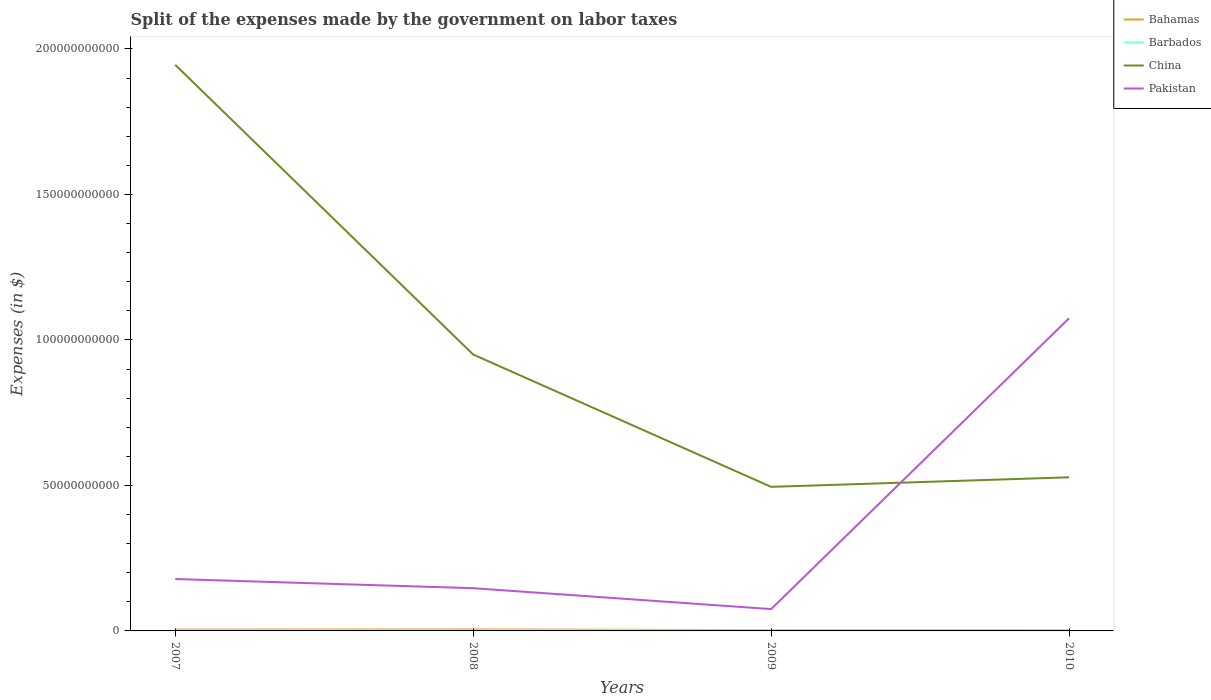Does the line corresponding to China intersect with the line corresponding to Pakistan?
Your response must be concise. Yes. Across all years, what is the maximum expenses made by the government on labor taxes in Pakistan?
Offer a very short reply. 7.50e+09. In which year was the expenses made by the government on labor taxes in Pakistan maximum?
Keep it short and to the point. 2009. What is the total expenses made by the government on labor taxes in China in the graph?
Your answer should be compact. 4.55e+1. What is the difference between the highest and the second highest expenses made by the government on labor taxes in China?
Ensure brevity in your answer.  1.45e+11. What is the difference between the highest and the lowest expenses made by the government on labor taxes in China?
Give a very brief answer. 1. How many lines are there?
Offer a terse response. 4. Are the values on the major ticks of Y-axis written in scientific E-notation?
Your answer should be compact. No. Does the graph contain any zero values?
Give a very brief answer. No. Does the graph contain grids?
Offer a terse response. No. How are the legend labels stacked?
Ensure brevity in your answer.  Vertical. What is the title of the graph?
Your answer should be compact. Split of the expenses made by the government on labor taxes. Does "Middle East & North Africa (all income levels)" appear as one of the legend labels in the graph?
Provide a short and direct response. No. What is the label or title of the Y-axis?
Your answer should be compact. Expenses (in $). What is the Expenses (in $) of Bahamas in 2007?
Your response must be concise. 4.46e+08. What is the Expenses (in $) in Barbados in 2007?
Offer a very short reply. 2.17e+08. What is the Expenses (in $) of China in 2007?
Your answer should be very brief. 1.95e+11. What is the Expenses (in $) in Pakistan in 2007?
Make the answer very short. 1.78e+1. What is the Expenses (in $) of Bahamas in 2008?
Your answer should be very brief. 4.99e+08. What is the Expenses (in $) in Barbados in 2008?
Give a very brief answer. 2.42e+08. What is the Expenses (in $) of China in 2008?
Ensure brevity in your answer.  9.50e+1. What is the Expenses (in $) of Pakistan in 2008?
Provide a short and direct response. 1.47e+1. What is the Expenses (in $) of Bahamas in 2009?
Give a very brief answer. 2.78e+08. What is the Expenses (in $) of Barbados in 2009?
Make the answer very short. 2.18e+08. What is the Expenses (in $) of China in 2009?
Give a very brief answer. 4.95e+1. What is the Expenses (in $) of Pakistan in 2009?
Offer a very short reply. 7.50e+09. What is the Expenses (in $) of Bahamas in 2010?
Your answer should be very brief. 2.53e+08. What is the Expenses (in $) in Barbados in 2010?
Your answer should be compact. 2.13e+08. What is the Expenses (in $) of China in 2010?
Your answer should be very brief. 5.28e+1. What is the Expenses (in $) in Pakistan in 2010?
Provide a short and direct response. 1.07e+11. Across all years, what is the maximum Expenses (in $) in Bahamas?
Your response must be concise. 4.99e+08. Across all years, what is the maximum Expenses (in $) in Barbados?
Offer a terse response. 2.42e+08. Across all years, what is the maximum Expenses (in $) in China?
Ensure brevity in your answer.  1.95e+11. Across all years, what is the maximum Expenses (in $) of Pakistan?
Offer a terse response. 1.07e+11. Across all years, what is the minimum Expenses (in $) of Bahamas?
Your answer should be very brief. 2.53e+08. Across all years, what is the minimum Expenses (in $) of Barbados?
Provide a succinct answer. 2.13e+08. Across all years, what is the minimum Expenses (in $) of China?
Your answer should be very brief. 4.95e+1. Across all years, what is the minimum Expenses (in $) of Pakistan?
Ensure brevity in your answer.  7.50e+09. What is the total Expenses (in $) in Bahamas in the graph?
Keep it short and to the point. 1.48e+09. What is the total Expenses (in $) in Barbados in the graph?
Provide a succinct answer. 8.90e+08. What is the total Expenses (in $) in China in the graph?
Your response must be concise. 3.92e+11. What is the total Expenses (in $) in Pakistan in the graph?
Provide a succinct answer. 1.47e+11. What is the difference between the Expenses (in $) in Bahamas in 2007 and that in 2008?
Offer a terse response. -5.32e+07. What is the difference between the Expenses (in $) of Barbados in 2007 and that in 2008?
Keep it short and to the point. -2.51e+07. What is the difference between the Expenses (in $) of China in 2007 and that in 2008?
Offer a terse response. 9.95e+1. What is the difference between the Expenses (in $) in Pakistan in 2007 and that in 2008?
Keep it short and to the point. 3.14e+09. What is the difference between the Expenses (in $) in Bahamas in 2007 and that in 2009?
Keep it short and to the point. 1.68e+08. What is the difference between the Expenses (in $) in Barbados in 2007 and that in 2009?
Keep it short and to the point. -1.56e+06. What is the difference between the Expenses (in $) in China in 2007 and that in 2009?
Offer a terse response. 1.45e+11. What is the difference between the Expenses (in $) of Pakistan in 2007 and that in 2009?
Offer a very short reply. 1.03e+1. What is the difference between the Expenses (in $) of Bahamas in 2007 and that in 2010?
Ensure brevity in your answer.  1.92e+08. What is the difference between the Expenses (in $) of Barbados in 2007 and that in 2010?
Provide a short and direct response. 3.69e+06. What is the difference between the Expenses (in $) in China in 2007 and that in 2010?
Make the answer very short. 1.42e+11. What is the difference between the Expenses (in $) of Pakistan in 2007 and that in 2010?
Your response must be concise. -8.96e+1. What is the difference between the Expenses (in $) in Bahamas in 2008 and that in 2009?
Provide a succinct answer. 2.21e+08. What is the difference between the Expenses (in $) in Barbados in 2008 and that in 2009?
Offer a terse response. 2.35e+07. What is the difference between the Expenses (in $) in China in 2008 and that in 2009?
Give a very brief answer. 4.55e+1. What is the difference between the Expenses (in $) of Pakistan in 2008 and that in 2009?
Give a very brief answer. 7.18e+09. What is the difference between the Expenses (in $) of Bahamas in 2008 and that in 2010?
Keep it short and to the point. 2.46e+08. What is the difference between the Expenses (in $) of Barbados in 2008 and that in 2010?
Keep it short and to the point. 2.88e+07. What is the difference between the Expenses (in $) in China in 2008 and that in 2010?
Your response must be concise. 4.22e+1. What is the difference between the Expenses (in $) in Pakistan in 2008 and that in 2010?
Provide a short and direct response. -9.28e+1. What is the difference between the Expenses (in $) in Bahamas in 2009 and that in 2010?
Give a very brief answer. 2.47e+07. What is the difference between the Expenses (in $) in Barbados in 2009 and that in 2010?
Your answer should be compact. 5.25e+06. What is the difference between the Expenses (in $) of China in 2009 and that in 2010?
Ensure brevity in your answer.  -3.28e+09. What is the difference between the Expenses (in $) of Pakistan in 2009 and that in 2010?
Ensure brevity in your answer.  -9.99e+1. What is the difference between the Expenses (in $) of Bahamas in 2007 and the Expenses (in $) of Barbados in 2008?
Keep it short and to the point. 2.04e+08. What is the difference between the Expenses (in $) of Bahamas in 2007 and the Expenses (in $) of China in 2008?
Keep it short and to the point. -9.45e+1. What is the difference between the Expenses (in $) in Bahamas in 2007 and the Expenses (in $) in Pakistan in 2008?
Your answer should be very brief. -1.42e+1. What is the difference between the Expenses (in $) in Barbados in 2007 and the Expenses (in $) in China in 2008?
Provide a short and direct response. -9.48e+1. What is the difference between the Expenses (in $) in Barbados in 2007 and the Expenses (in $) in Pakistan in 2008?
Provide a succinct answer. -1.45e+1. What is the difference between the Expenses (in $) in China in 2007 and the Expenses (in $) in Pakistan in 2008?
Offer a terse response. 1.80e+11. What is the difference between the Expenses (in $) in Bahamas in 2007 and the Expenses (in $) in Barbados in 2009?
Make the answer very short. 2.27e+08. What is the difference between the Expenses (in $) in Bahamas in 2007 and the Expenses (in $) in China in 2009?
Your answer should be compact. -4.91e+1. What is the difference between the Expenses (in $) of Bahamas in 2007 and the Expenses (in $) of Pakistan in 2009?
Keep it short and to the point. -7.06e+09. What is the difference between the Expenses (in $) of Barbados in 2007 and the Expenses (in $) of China in 2009?
Offer a terse response. -4.93e+1. What is the difference between the Expenses (in $) of Barbados in 2007 and the Expenses (in $) of Pakistan in 2009?
Your answer should be very brief. -7.29e+09. What is the difference between the Expenses (in $) in China in 2007 and the Expenses (in $) in Pakistan in 2009?
Provide a succinct answer. 1.87e+11. What is the difference between the Expenses (in $) in Bahamas in 2007 and the Expenses (in $) in Barbados in 2010?
Make the answer very short. 2.32e+08. What is the difference between the Expenses (in $) in Bahamas in 2007 and the Expenses (in $) in China in 2010?
Offer a very short reply. -5.23e+1. What is the difference between the Expenses (in $) of Bahamas in 2007 and the Expenses (in $) of Pakistan in 2010?
Make the answer very short. -1.07e+11. What is the difference between the Expenses (in $) in Barbados in 2007 and the Expenses (in $) in China in 2010?
Your response must be concise. -5.26e+1. What is the difference between the Expenses (in $) of Barbados in 2007 and the Expenses (in $) of Pakistan in 2010?
Your answer should be compact. -1.07e+11. What is the difference between the Expenses (in $) in China in 2007 and the Expenses (in $) in Pakistan in 2010?
Offer a very short reply. 8.71e+1. What is the difference between the Expenses (in $) in Bahamas in 2008 and the Expenses (in $) in Barbados in 2009?
Offer a very short reply. 2.80e+08. What is the difference between the Expenses (in $) of Bahamas in 2008 and the Expenses (in $) of China in 2009?
Keep it short and to the point. -4.90e+1. What is the difference between the Expenses (in $) in Bahamas in 2008 and the Expenses (in $) in Pakistan in 2009?
Keep it short and to the point. -7.00e+09. What is the difference between the Expenses (in $) of Barbados in 2008 and the Expenses (in $) of China in 2009?
Your answer should be very brief. -4.93e+1. What is the difference between the Expenses (in $) of Barbados in 2008 and the Expenses (in $) of Pakistan in 2009?
Make the answer very short. -7.26e+09. What is the difference between the Expenses (in $) of China in 2008 and the Expenses (in $) of Pakistan in 2009?
Give a very brief answer. 8.75e+1. What is the difference between the Expenses (in $) of Bahamas in 2008 and the Expenses (in $) of Barbados in 2010?
Your answer should be very brief. 2.86e+08. What is the difference between the Expenses (in $) in Bahamas in 2008 and the Expenses (in $) in China in 2010?
Offer a very short reply. -5.23e+1. What is the difference between the Expenses (in $) of Bahamas in 2008 and the Expenses (in $) of Pakistan in 2010?
Offer a terse response. -1.07e+11. What is the difference between the Expenses (in $) of Barbados in 2008 and the Expenses (in $) of China in 2010?
Offer a very short reply. -5.25e+1. What is the difference between the Expenses (in $) in Barbados in 2008 and the Expenses (in $) in Pakistan in 2010?
Provide a short and direct response. -1.07e+11. What is the difference between the Expenses (in $) in China in 2008 and the Expenses (in $) in Pakistan in 2010?
Keep it short and to the point. -1.25e+1. What is the difference between the Expenses (in $) in Bahamas in 2009 and the Expenses (in $) in Barbados in 2010?
Provide a succinct answer. 6.47e+07. What is the difference between the Expenses (in $) in Bahamas in 2009 and the Expenses (in $) in China in 2010?
Your response must be concise. -5.25e+1. What is the difference between the Expenses (in $) of Bahamas in 2009 and the Expenses (in $) of Pakistan in 2010?
Give a very brief answer. -1.07e+11. What is the difference between the Expenses (in $) in Barbados in 2009 and the Expenses (in $) in China in 2010?
Make the answer very short. -5.26e+1. What is the difference between the Expenses (in $) in Barbados in 2009 and the Expenses (in $) in Pakistan in 2010?
Make the answer very short. -1.07e+11. What is the difference between the Expenses (in $) of China in 2009 and the Expenses (in $) of Pakistan in 2010?
Make the answer very short. -5.79e+1. What is the average Expenses (in $) of Bahamas per year?
Keep it short and to the point. 3.69e+08. What is the average Expenses (in $) in Barbados per year?
Keep it short and to the point. 2.23e+08. What is the average Expenses (in $) of China per year?
Your response must be concise. 9.79e+1. What is the average Expenses (in $) of Pakistan per year?
Offer a very short reply. 3.69e+1. In the year 2007, what is the difference between the Expenses (in $) in Bahamas and Expenses (in $) in Barbados?
Ensure brevity in your answer.  2.29e+08. In the year 2007, what is the difference between the Expenses (in $) of Bahamas and Expenses (in $) of China?
Offer a terse response. -1.94e+11. In the year 2007, what is the difference between the Expenses (in $) of Bahamas and Expenses (in $) of Pakistan?
Provide a short and direct response. -1.74e+1. In the year 2007, what is the difference between the Expenses (in $) in Barbados and Expenses (in $) in China?
Your answer should be very brief. -1.94e+11. In the year 2007, what is the difference between the Expenses (in $) of Barbados and Expenses (in $) of Pakistan?
Offer a very short reply. -1.76e+1. In the year 2007, what is the difference between the Expenses (in $) of China and Expenses (in $) of Pakistan?
Provide a short and direct response. 1.77e+11. In the year 2008, what is the difference between the Expenses (in $) in Bahamas and Expenses (in $) in Barbados?
Provide a short and direct response. 2.57e+08. In the year 2008, what is the difference between the Expenses (in $) of Bahamas and Expenses (in $) of China?
Offer a very short reply. -9.45e+1. In the year 2008, what is the difference between the Expenses (in $) in Bahamas and Expenses (in $) in Pakistan?
Offer a terse response. -1.42e+1. In the year 2008, what is the difference between the Expenses (in $) of Barbados and Expenses (in $) of China?
Offer a very short reply. -9.47e+1. In the year 2008, what is the difference between the Expenses (in $) in Barbados and Expenses (in $) in Pakistan?
Your response must be concise. -1.44e+1. In the year 2008, what is the difference between the Expenses (in $) in China and Expenses (in $) in Pakistan?
Your response must be concise. 8.03e+1. In the year 2009, what is the difference between the Expenses (in $) of Bahamas and Expenses (in $) of Barbados?
Your answer should be compact. 5.95e+07. In the year 2009, what is the difference between the Expenses (in $) of Bahamas and Expenses (in $) of China?
Give a very brief answer. -4.92e+1. In the year 2009, what is the difference between the Expenses (in $) in Bahamas and Expenses (in $) in Pakistan?
Ensure brevity in your answer.  -7.23e+09. In the year 2009, what is the difference between the Expenses (in $) of Barbados and Expenses (in $) of China?
Provide a succinct answer. -4.93e+1. In the year 2009, what is the difference between the Expenses (in $) of Barbados and Expenses (in $) of Pakistan?
Your answer should be very brief. -7.28e+09. In the year 2009, what is the difference between the Expenses (in $) of China and Expenses (in $) of Pakistan?
Your response must be concise. 4.20e+1. In the year 2010, what is the difference between the Expenses (in $) of Bahamas and Expenses (in $) of Barbados?
Your answer should be very brief. 4.00e+07. In the year 2010, what is the difference between the Expenses (in $) of Bahamas and Expenses (in $) of China?
Ensure brevity in your answer.  -5.25e+1. In the year 2010, what is the difference between the Expenses (in $) in Bahamas and Expenses (in $) in Pakistan?
Your answer should be very brief. -1.07e+11. In the year 2010, what is the difference between the Expenses (in $) of Barbados and Expenses (in $) of China?
Offer a terse response. -5.26e+1. In the year 2010, what is the difference between the Expenses (in $) of Barbados and Expenses (in $) of Pakistan?
Provide a succinct answer. -1.07e+11. In the year 2010, what is the difference between the Expenses (in $) of China and Expenses (in $) of Pakistan?
Make the answer very short. -5.47e+1. What is the ratio of the Expenses (in $) in Bahamas in 2007 to that in 2008?
Provide a short and direct response. 0.89. What is the ratio of the Expenses (in $) in Barbados in 2007 to that in 2008?
Provide a short and direct response. 0.9. What is the ratio of the Expenses (in $) of China in 2007 to that in 2008?
Give a very brief answer. 2.05. What is the ratio of the Expenses (in $) of Pakistan in 2007 to that in 2008?
Ensure brevity in your answer.  1.21. What is the ratio of the Expenses (in $) in Bahamas in 2007 to that in 2009?
Your answer should be very brief. 1.6. What is the ratio of the Expenses (in $) of China in 2007 to that in 2009?
Keep it short and to the point. 3.93. What is the ratio of the Expenses (in $) of Pakistan in 2007 to that in 2009?
Make the answer very short. 2.38. What is the ratio of the Expenses (in $) of Bahamas in 2007 to that in 2010?
Ensure brevity in your answer.  1.76. What is the ratio of the Expenses (in $) in Barbados in 2007 to that in 2010?
Your answer should be very brief. 1.02. What is the ratio of the Expenses (in $) in China in 2007 to that in 2010?
Offer a terse response. 3.69. What is the ratio of the Expenses (in $) in Pakistan in 2007 to that in 2010?
Your answer should be very brief. 0.17. What is the ratio of the Expenses (in $) in Bahamas in 2008 to that in 2009?
Your response must be concise. 1.79. What is the ratio of the Expenses (in $) of Barbados in 2008 to that in 2009?
Offer a terse response. 1.11. What is the ratio of the Expenses (in $) of China in 2008 to that in 2009?
Keep it short and to the point. 1.92. What is the ratio of the Expenses (in $) of Pakistan in 2008 to that in 2009?
Your answer should be compact. 1.96. What is the ratio of the Expenses (in $) of Bahamas in 2008 to that in 2010?
Offer a terse response. 1.97. What is the ratio of the Expenses (in $) in Barbados in 2008 to that in 2010?
Offer a very short reply. 1.14. What is the ratio of the Expenses (in $) in China in 2008 to that in 2010?
Keep it short and to the point. 1.8. What is the ratio of the Expenses (in $) of Pakistan in 2008 to that in 2010?
Offer a very short reply. 0.14. What is the ratio of the Expenses (in $) in Bahamas in 2009 to that in 2010?
Offer a terse response. 1.1. What is the ratio of the Expenses (in $) of Barbados in 2009 to that in 2010?
Your answer should be very brief. 1.02. What is the ratio of the Expenses (in $) in China in 2009 to that in 2010?
Your answer should be compact. 0.94. What is the ratio of the Expenses (in $) in Pakistan in 2009 to that in 2010?
Offer a very short reply. 0.07. What is the difference between the highest and the second highest Expenses (in $) of Bahamas?
Your answer should be very brief. 5.32e+07. What is the difference between the highest and the second highest Expenses (in $) in Barbados?
Offer a very short reply. 2.35e+07. What is the difference between the highest and the second highest Expenses (in $) in China?
Offer a terse response. 9.95e+1. What is the difference between the highest and the second highest Expenses (in $) of Pakistan?
Your answer should be very brief. 8.96e+1. What is the difference between the highest and the lowest Expenses (in $) in Bahamas?
Keep it short and to the point. 2.46e+08. What is the difference between the highest and the lowest Expenses (in $) of Barbados?
Provide a short and direct response. 2.88e+07. What is the difference between the highest and the lowest Expenses (in $) of China?
Make the answer very short. 1.45e+11. What is the difference between the highest and the lowest Expenses (in $) in Pakistan?
Offer a very short reply. 9.99e+1. 